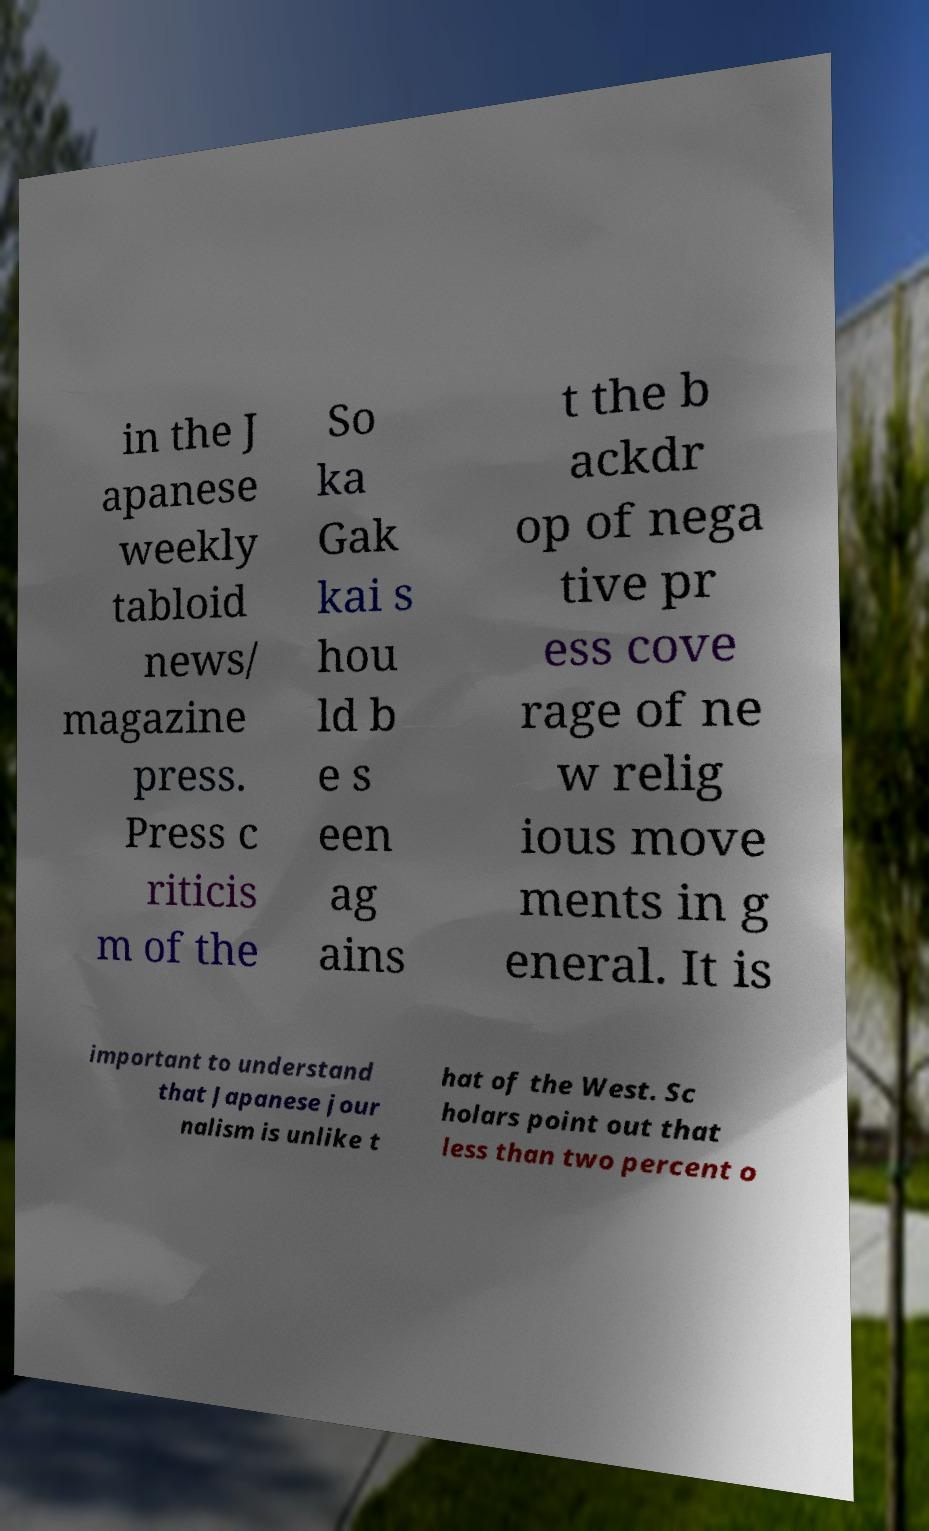I need the written content from this picture converted into text. Can you do that? in the J apanese weekly tabloid news/ magazine press. Press c riticis m of the So ka Gak kai s hou ld b e s een ag ains t the b ackdr op of nega tive pr ess cove rage of ne w relig ious move ments in g eneral. It is important to understand that Japanese jour nalism is unlike t hat of the West. Sc holars point out that less than two percent o 